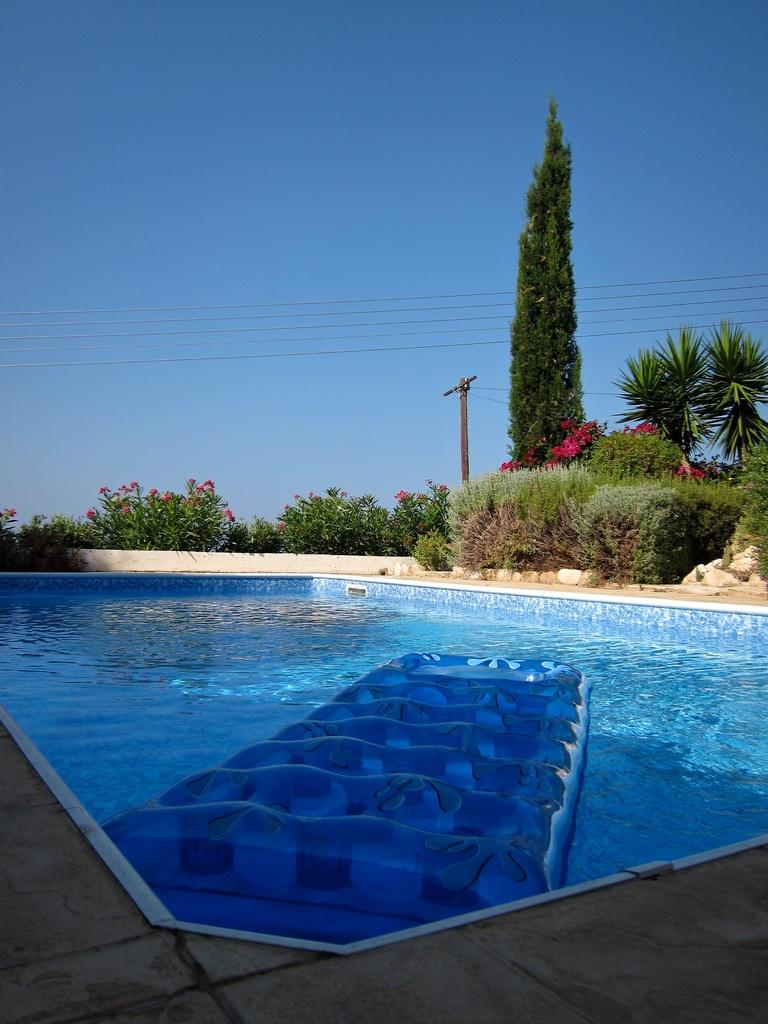What is the main feature in the image? There is a swimming pool in the image. What can be seen floating on the water in the pool? There is a blue object floating on the water in the pool. Can you describe the surroundings of the pool? There is a path visible in the image, and there are plants and a tree in the background. What else can be seen in the background of the image? There are wires and the sky is clear and visible in the background of the image. What type of writing can be seen on the bear's shirt in the image? There is no bear or writing present in the image. What border is visible around the swimming pool in the image? There is no border visible around the swimming pool in the image. 